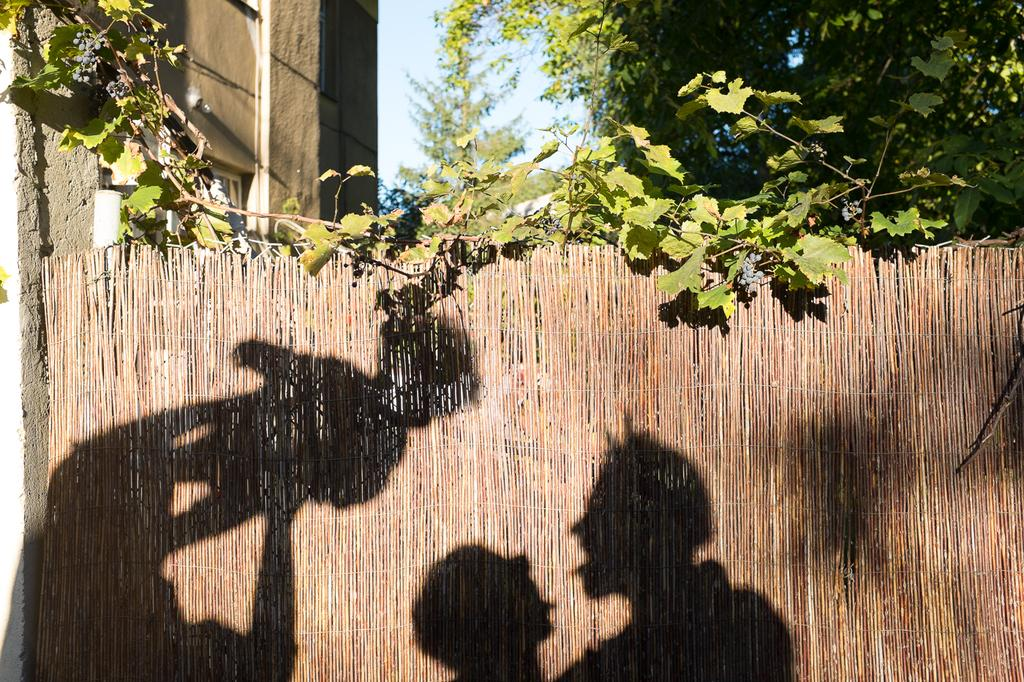What can be seen on the wooden fence in the image? There are shadows of people on the wooden fence. What type of vegetation is present in the image? There are trees in the image. What structure can be seen in the image? There is a wall in the image. What is visible in the background of the image? The sky is visible in the background of the image. Can you tell me how many giraffes are visible in the image? There are no giraffes present in the image. What type of wax is used to create the shadows on the wooden fence? There is no wax used to create the shadows in the image; they are formed by the interaction of light and the people casting the shadows. 